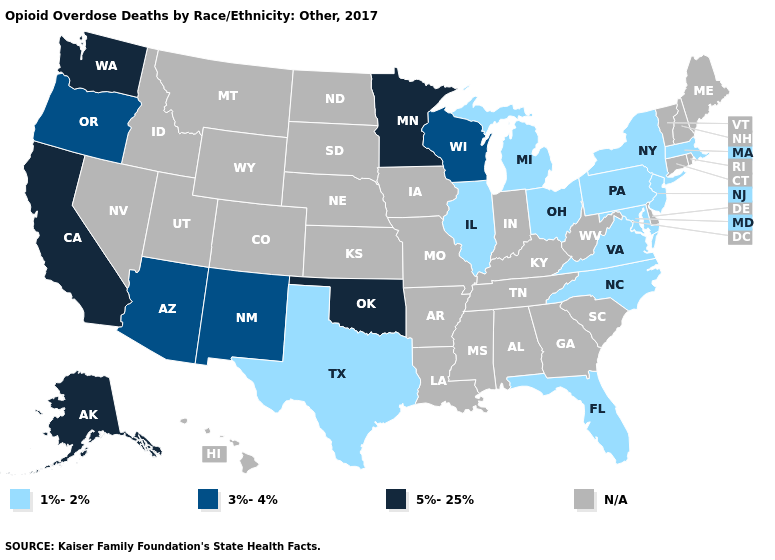Among the states that border Idaho , does Oregon have the highest value?
Short answer required. No. How many symbols are there in the legend?
Be succinct. 4. Which states have the lowest value in the West?
Quick response, please. Arizona, New Mexico, Oregon. Which states have the lowest value in the West?
Be succinct. Arizona, New Mexico, Oregon. Does the map have missing data?
Keep it brief. Yes. What is the lowest value in the Northeast?
Answer briefly. 1%-2%. What is the lowest value in the USA?
Be succinct. 1%-2%. What is the lowest value in states that border Tennessee?
Be succinct. 1%-2%. Name the states that have a value in the range 1%-2%?
Keep it brief. Florida, Illinois, Maryland, Massachusetts, Michigan, New Jersey, New York, North Carolina, Ohio, Pennsylvania, Texas, Virginia. What is the value of Utah?
Give a very brief answer. N/A. Is the legend a continuous bar?
Quick response, please. No. Which states have the lowest value in the South?
Write a very short answer. Florida, Maryland, North Carolina, Texas, Virginia. Name the states that have a value in the range N/A?
Answer briefly. Alabama, Arkansas, Colorado, Connecticut, Delaware, Georgia, Hawaii, Idaho, Indiana, Iowa, Kansas, Kentucky, Louisiana, Maine, Mississippi, Missouri, Montana, Nebraska, Nevada, New Hampshire, North Dakota, Rhode Island, South Carolina, South Dakota, Tennessee, Utah, Vermont, West Virginia, Wyoming. What is the value of Montana?
Answer briefly. N/A. 